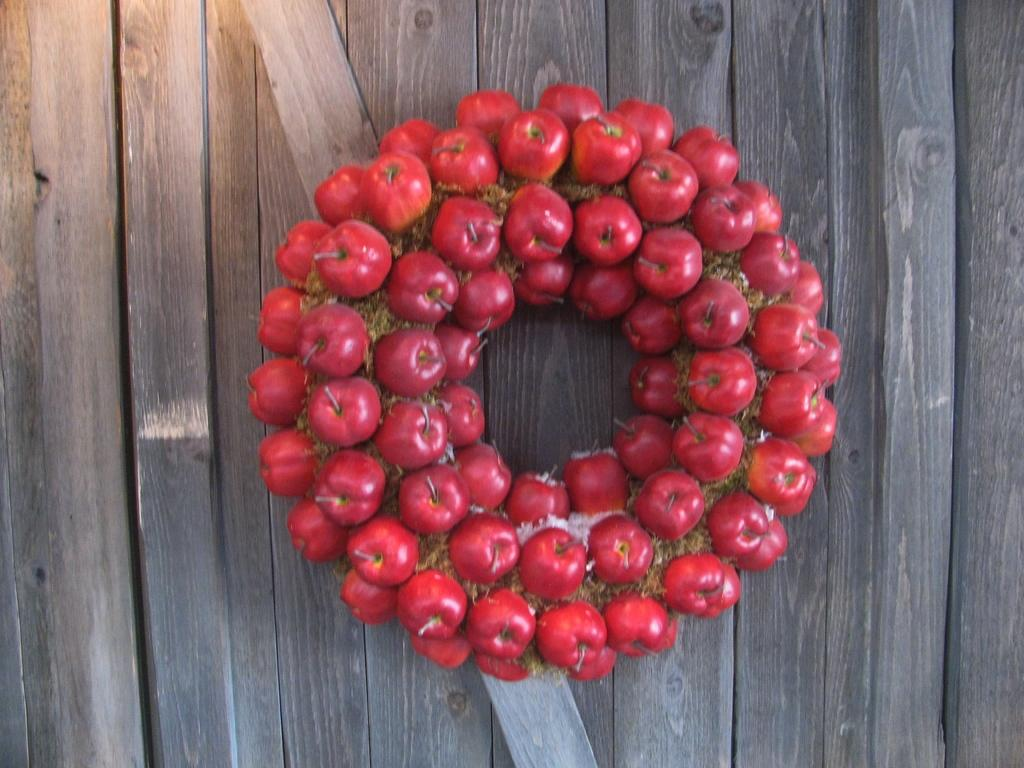What type of fruit is visible in the image? There are berries in the image. Where are the berries located in the image? The berries are in the center of the image. What surface are the berries resting on? The berries are on a wooden surface. What type of game is being played with the berries in the image? There is no game being played with the berries in the image; they are simply resting on a wooden surface. 